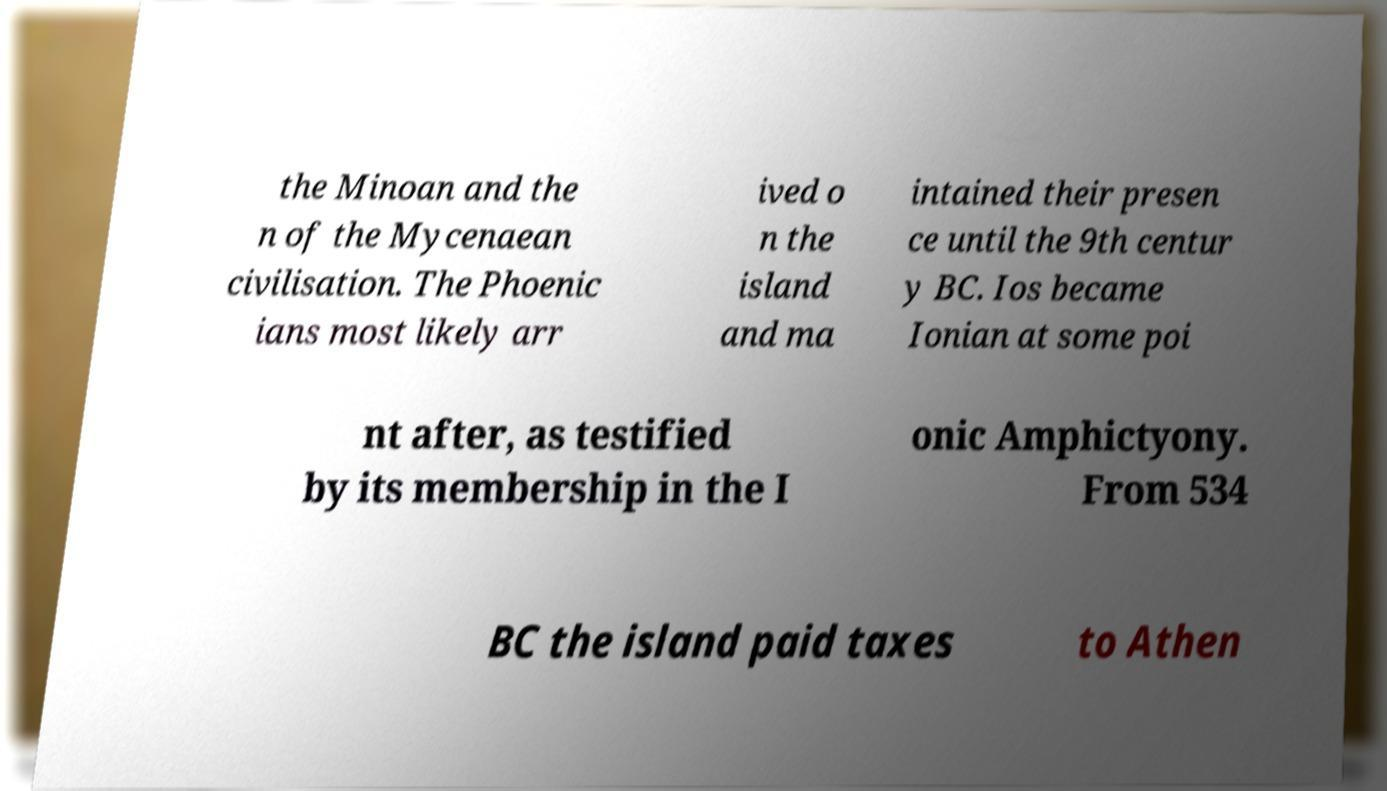There's text embedded in this image that I need extracted. Can you transcribe it verbatim? the Minoan and the n of the Mycenaean civilisation. The Phoenic ians most likely arr ived o n the island and ma intained their presen ce until the 9th centur y BC. Ios became Ionian at some poi nt after, as testified by its membership in the I onic Amphictyony. From 534 BC the island paid taxes to Athen 